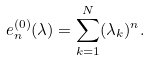Convert formula to latex. <formula><loc_0><loc_0><loc_500><loc_500>e _ { n } ^ { ( 0 ) } ( \lambda ) = \sum _ { k = 1 } ^ { N } ( \lambda _ { k } ) ^ { n } .</formula> 